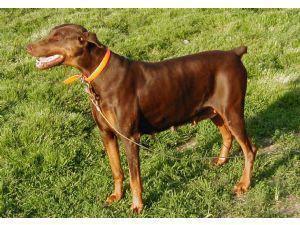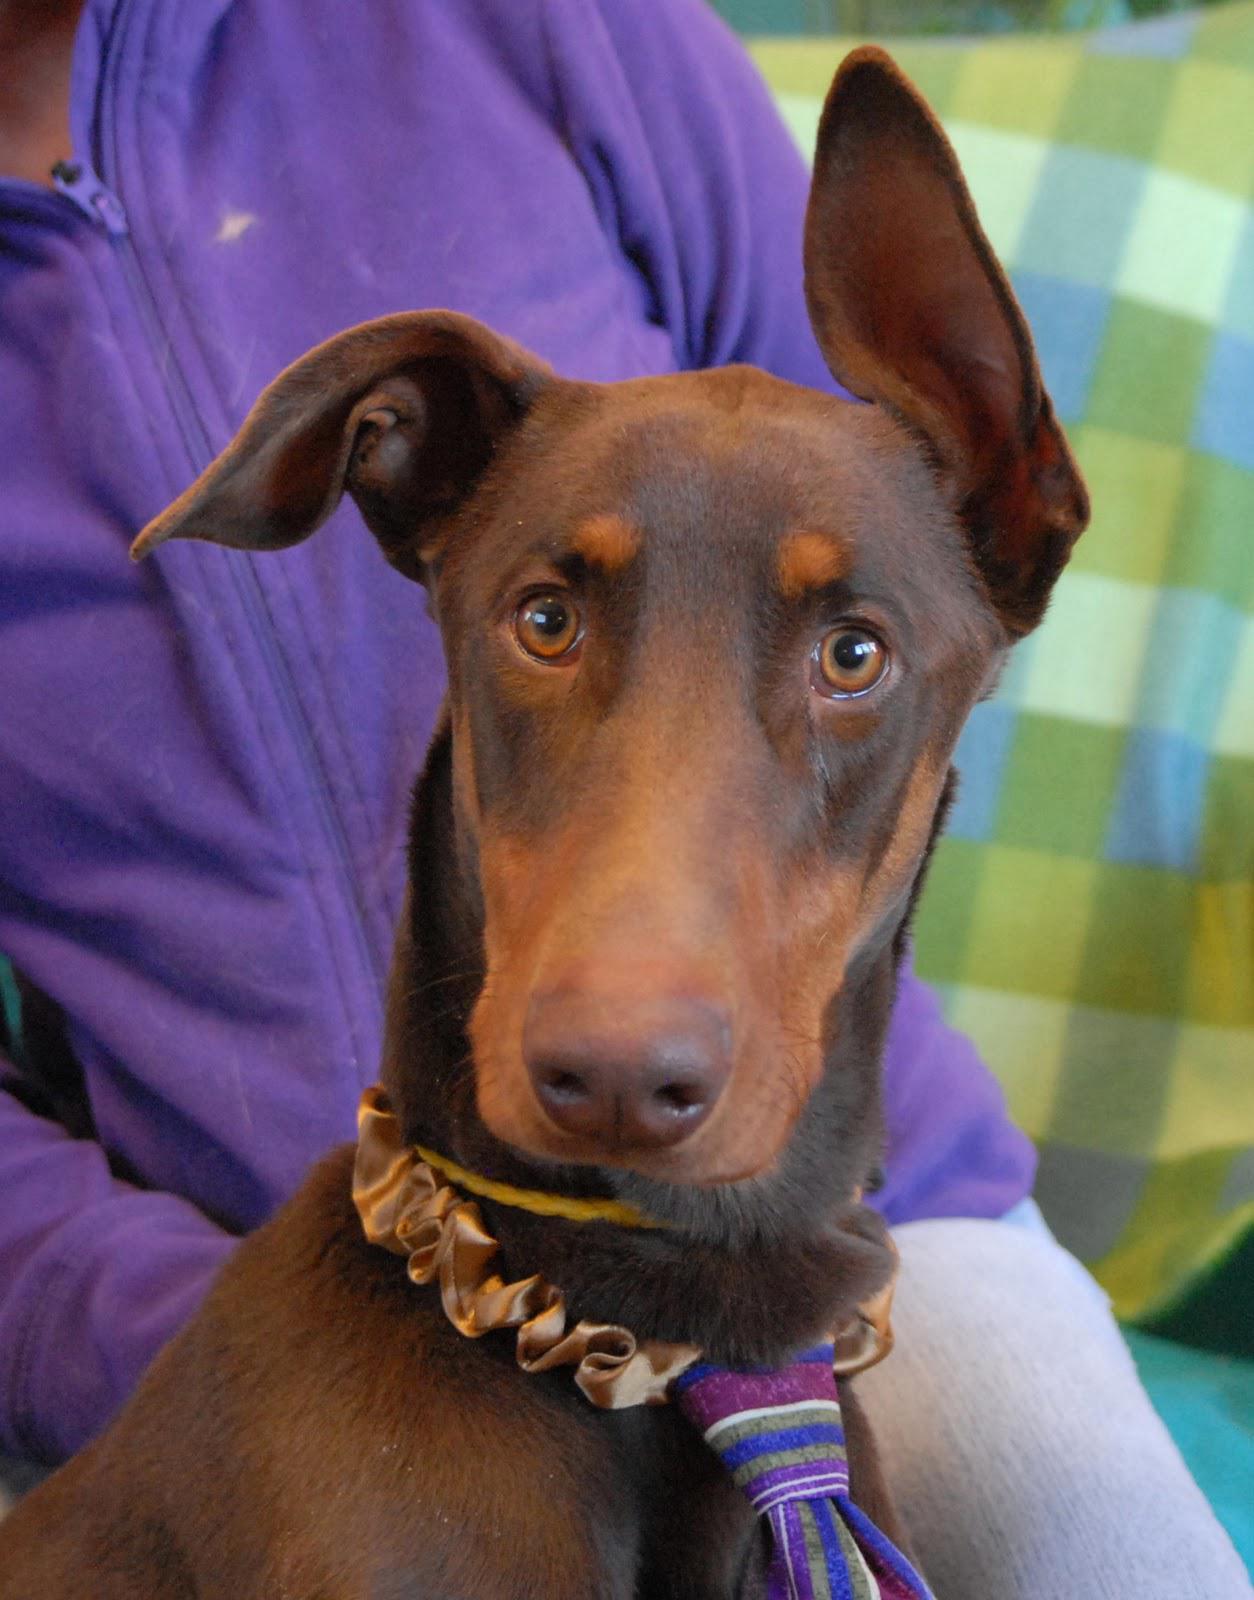The first image is the image on the left, the second image is the image on the right. Evaluate the accuracy of this statement regarding the images: "There is a total of two brown dogs.". Is it true? Answer yes or no. Yes. The first image is the image on the left, the second image is the image on the right. Evaluate the accuracy of this statement regarding the images: "There are exactly two dogs.". Is it true? Answer yes or no. Yes. 